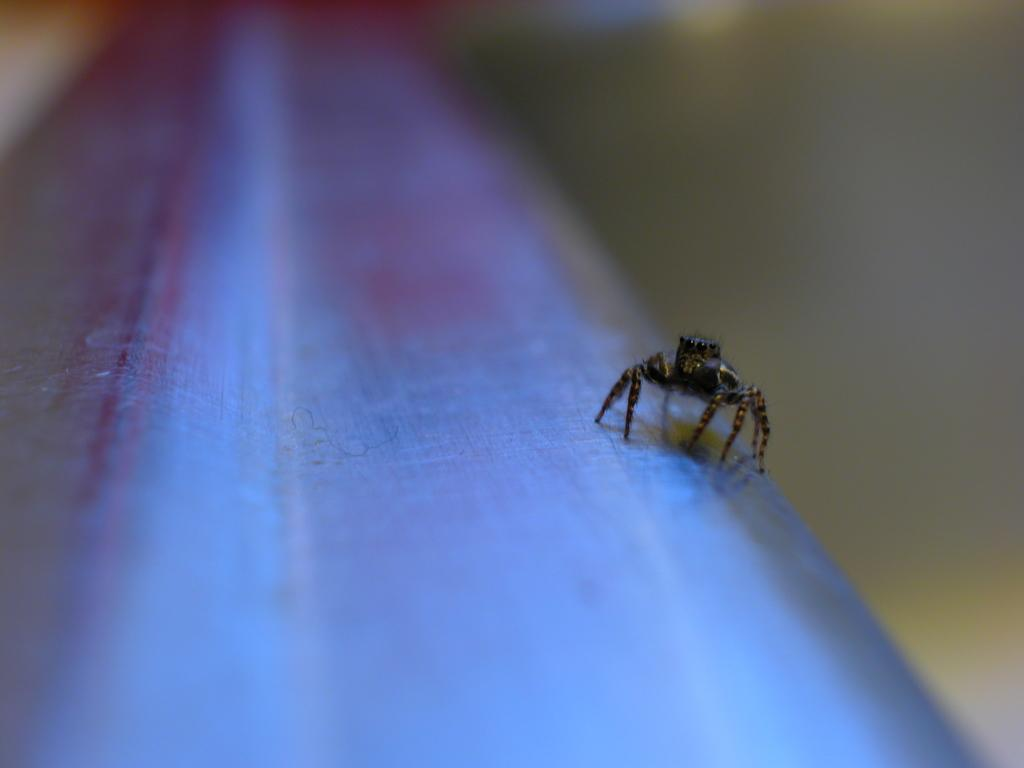What is the main subject of the picture? The main subject of the picture is an insect. Where is the insect located in the image? The insect is on an object. Can you describe the background of the image? The background of the image is blurred. What type of volcano can be seen erupting in the background of the image? There is no volcano present in the image; the background is blurred. What type of desk is the insect sitting on in the image? There is no desk present in the image; the insect is on an object, but it is not specified as a desk. 